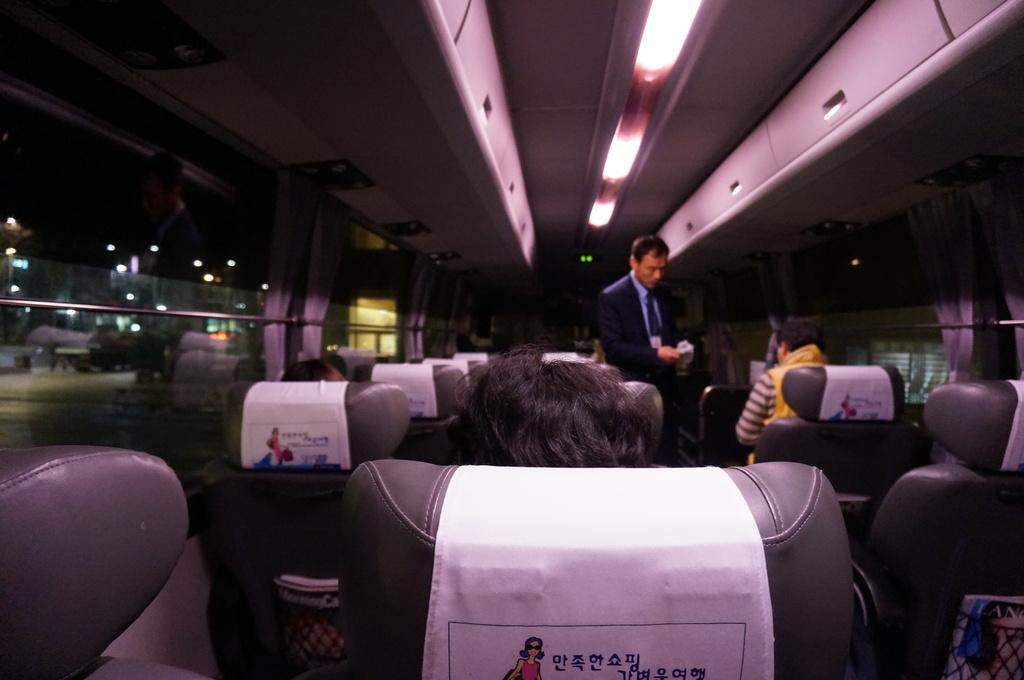Could you give a brief overview of what you see in this image? This image is taken in the bus. In this image there are seats and we can see people sitting. There is a man standing. At the top there are lights and we can see curtains. 